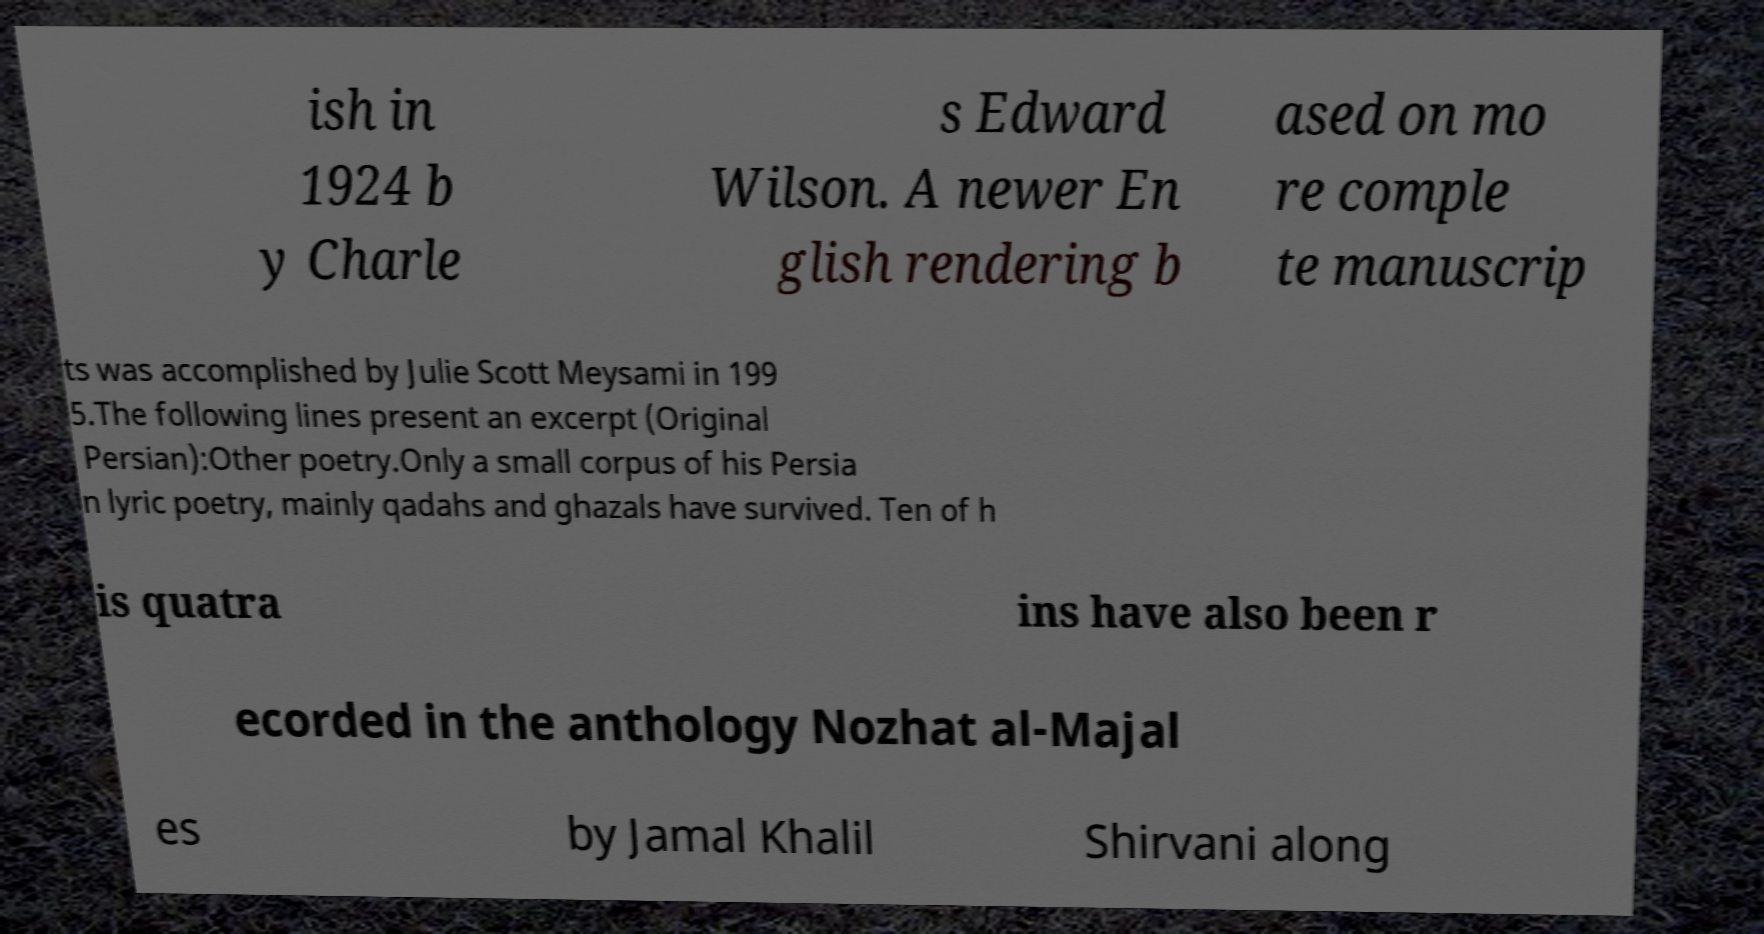For documentation purposes, I need the text within this image transcribed. Could you provide that? ish in 1924 b y Charle s Edward Wilson. A newer En glish rendering b ased on mo re comple te manuscrip ts was accomplished by Julie Scott Meysami in 199 5.The following lines present an excerpt (Original Persian):Other poetry.Only a small corpus of his Persia n lyric poetry, mainly qadahs and ghazals have survived. Ten of h is quatra ins have also been r ecorded in the anthology Nozhat al-Majal es by Jamal Khalil Shirvani along 